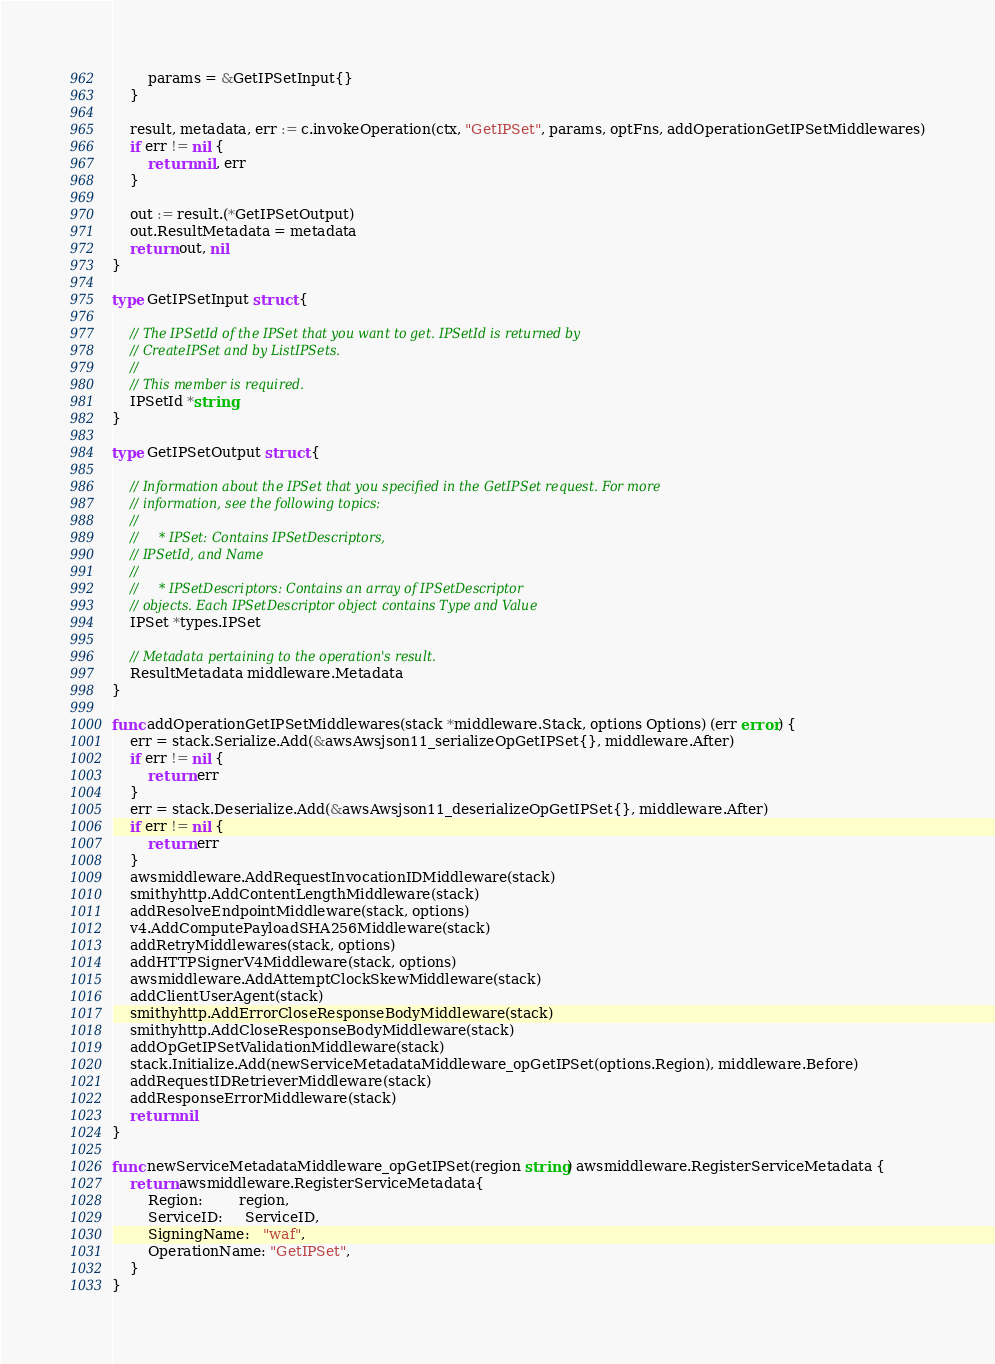Convert code to text. <code><loc_0><loc_0><loc_500><loc_500><_Go_>		params = &GetIPSetInput{}
	}

	result, metadata, err := c.invokeOperation(ctx, "GetIPSet", params, optFns, addOperationGetIPSetMiddlewares)
	if err != nil {
		return nil, err
	}

	out := result.(*GetIPSetOutput)
	out.ResultMetadata = metadata
	return out, nil
}

type GetIPSetInput struct {

	// The IPSetId of the IPSet that you want to get. IPSetId is returned by
	// CreateIPSet and by ListIPSets.
	//
	// This member is required.
	IPSetId *string
}

type GetIPSetOutput struct {

	// Information about the IPSet that you specified in the GetIPSet request. For more
	// information, see the following topics:
	//
	//     * IPSet: Contains IPSetDescriptors,
	// IPSetId, and Name
	//
	//     * IPSetDescriptors: Contains an array of IPSetDescriptor
	// objects. Each IPSetDescriptor object contains Type and Value
	IPSet *types.IPSet

	// Metadata pertaining to the operation's result.
	ResultMetadata middleware.Metadata
}

func addOperationGetIPSetMiddlewares(stack *middleware.Stack, options Options) (err error) {
	err = stack.Serialize.Add(&awsAwsjson11_serializeOpGetIPSet{}, middleware.After)
	if err != nil {
		return err
	}
	err = stack.Deserialize.Add(&awsAwsjson11_deserializeOpGetIPSet{}, middleware.After)
	if err != nil {
		return err
	}
	awsmiddleware.AddRequestInvocationIDMiddleware(stack)
	smithyhttp.AddContentLengthMiddleware(stack)
	addResolveEndpointMiddleware(stack, options)
	v4.AddComputePayloadSHA256Middleware(stack)
	addRetryMiddlewares(stack, options)
	addHTTPSignerV4Middleware(stack, options)
	awsmiddleware.AddAttemptClockSkewMiddleware(stack)
	addClientUserAgent(stack)
	smithyhttp.AddErrorCloseResponseBodyMiddleware(stack)
	smithyhttp.AddCloseResponseBodyMiddleware(stack)
	addOpGetIPSetValidationMiddleware(stack)
	stack.Initialize.Add(newServiceMetadataMiddleware_opGetIPSet(options.Region), middleware.Before)
	addRequestIDRetrieverMiddleware(stack)
	addResponseErrorMiddleware(stack)
	return nil
}

func newServiceMetadataMiddleware_opGetIPSet(region string) awsmiddleware.RegisterServiceMetadata {
	return awsmiddleware.RegisterServiceMetadata{
		Region:        region,
		ServiceID:     ServiceID,
		SigningName:   "waf",
		OperationName: "GetIPSet",
	}
}
</code> 